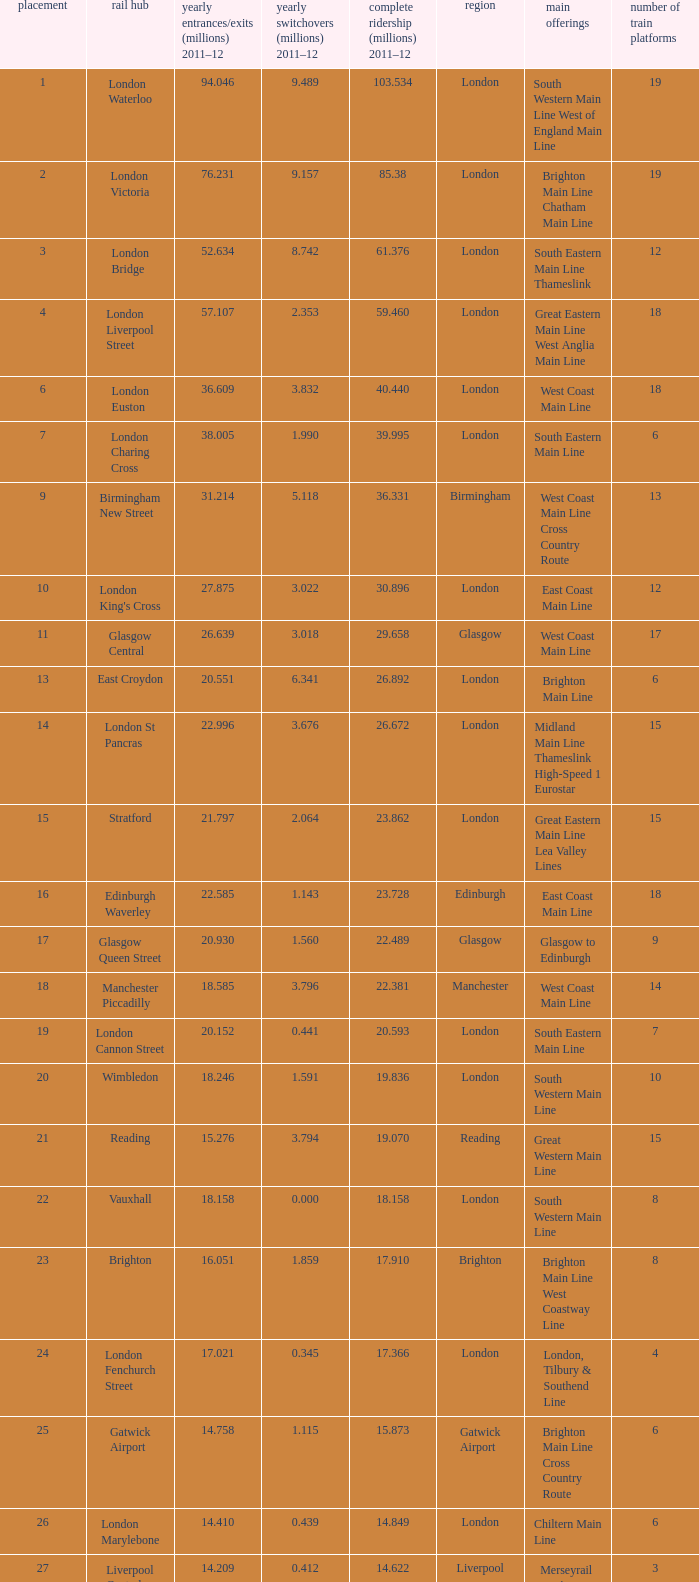What is the lowest rank of Gatwick Airport?  25.0. 